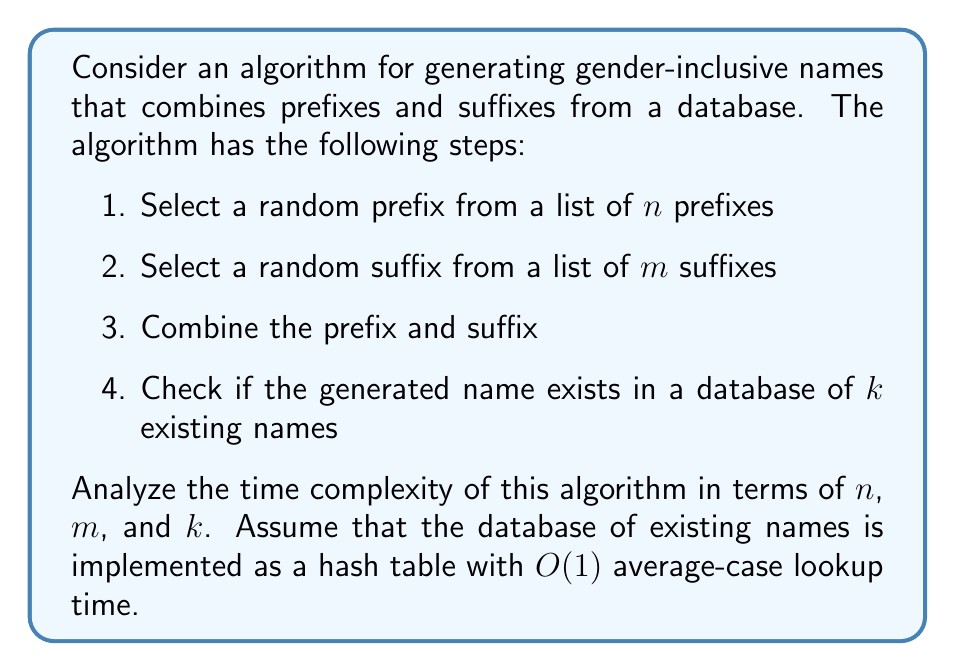Can you solve this math problem? To analyze the time complexity of this algorithm, we need to consider each step:

1. Selecting a random prefix:
   This operation typically takes $O(1)$ time if we use a uniform random number generator to select an index between 0 and $n-1$.

2. Selecting a random suffix:
   Similarly, this operation takes $O(1)$ time.

3. Combining the prefix and suffix:
   String concatenation in most programming languages is an $O(l)$ operation, where $l$ is the length of the resulting string. In this case, we can assume that the length of the name is constant or bounded, so this step takes $O(1)$ time.

4. Checking if the generated name exists in the database:
   Since the database is implemented as a hash table with $O(1)$ average-case lookup time, this step takes $O(1)$ time.

The total time complexity is the sum of the time complexities of each step:

$$ T(n,m,k) = O(1) + O(1) + O(1) + O(1) = O(1) $$

It's important to note that this analysis assumes:
- The random selection of prefixes and suffixes is truly $O(1)$
- The string concatenation is bounded
- The hash table lookup is average-case $O(1)$

In practice, the actual time might depend on the implementation details of these operations, but for the purpose of this analysis, we consider them constant time.

The size of the input ($n$, $m$, and $k$) does not affect the time complexity of a single name generation, as we're not iterating through these lists or the database. However, these sizes would affect the space complexity and the diversity of generated names.
Answer: The time complexity of the gender-inclusive name generation algorithm is $O(1)$. 